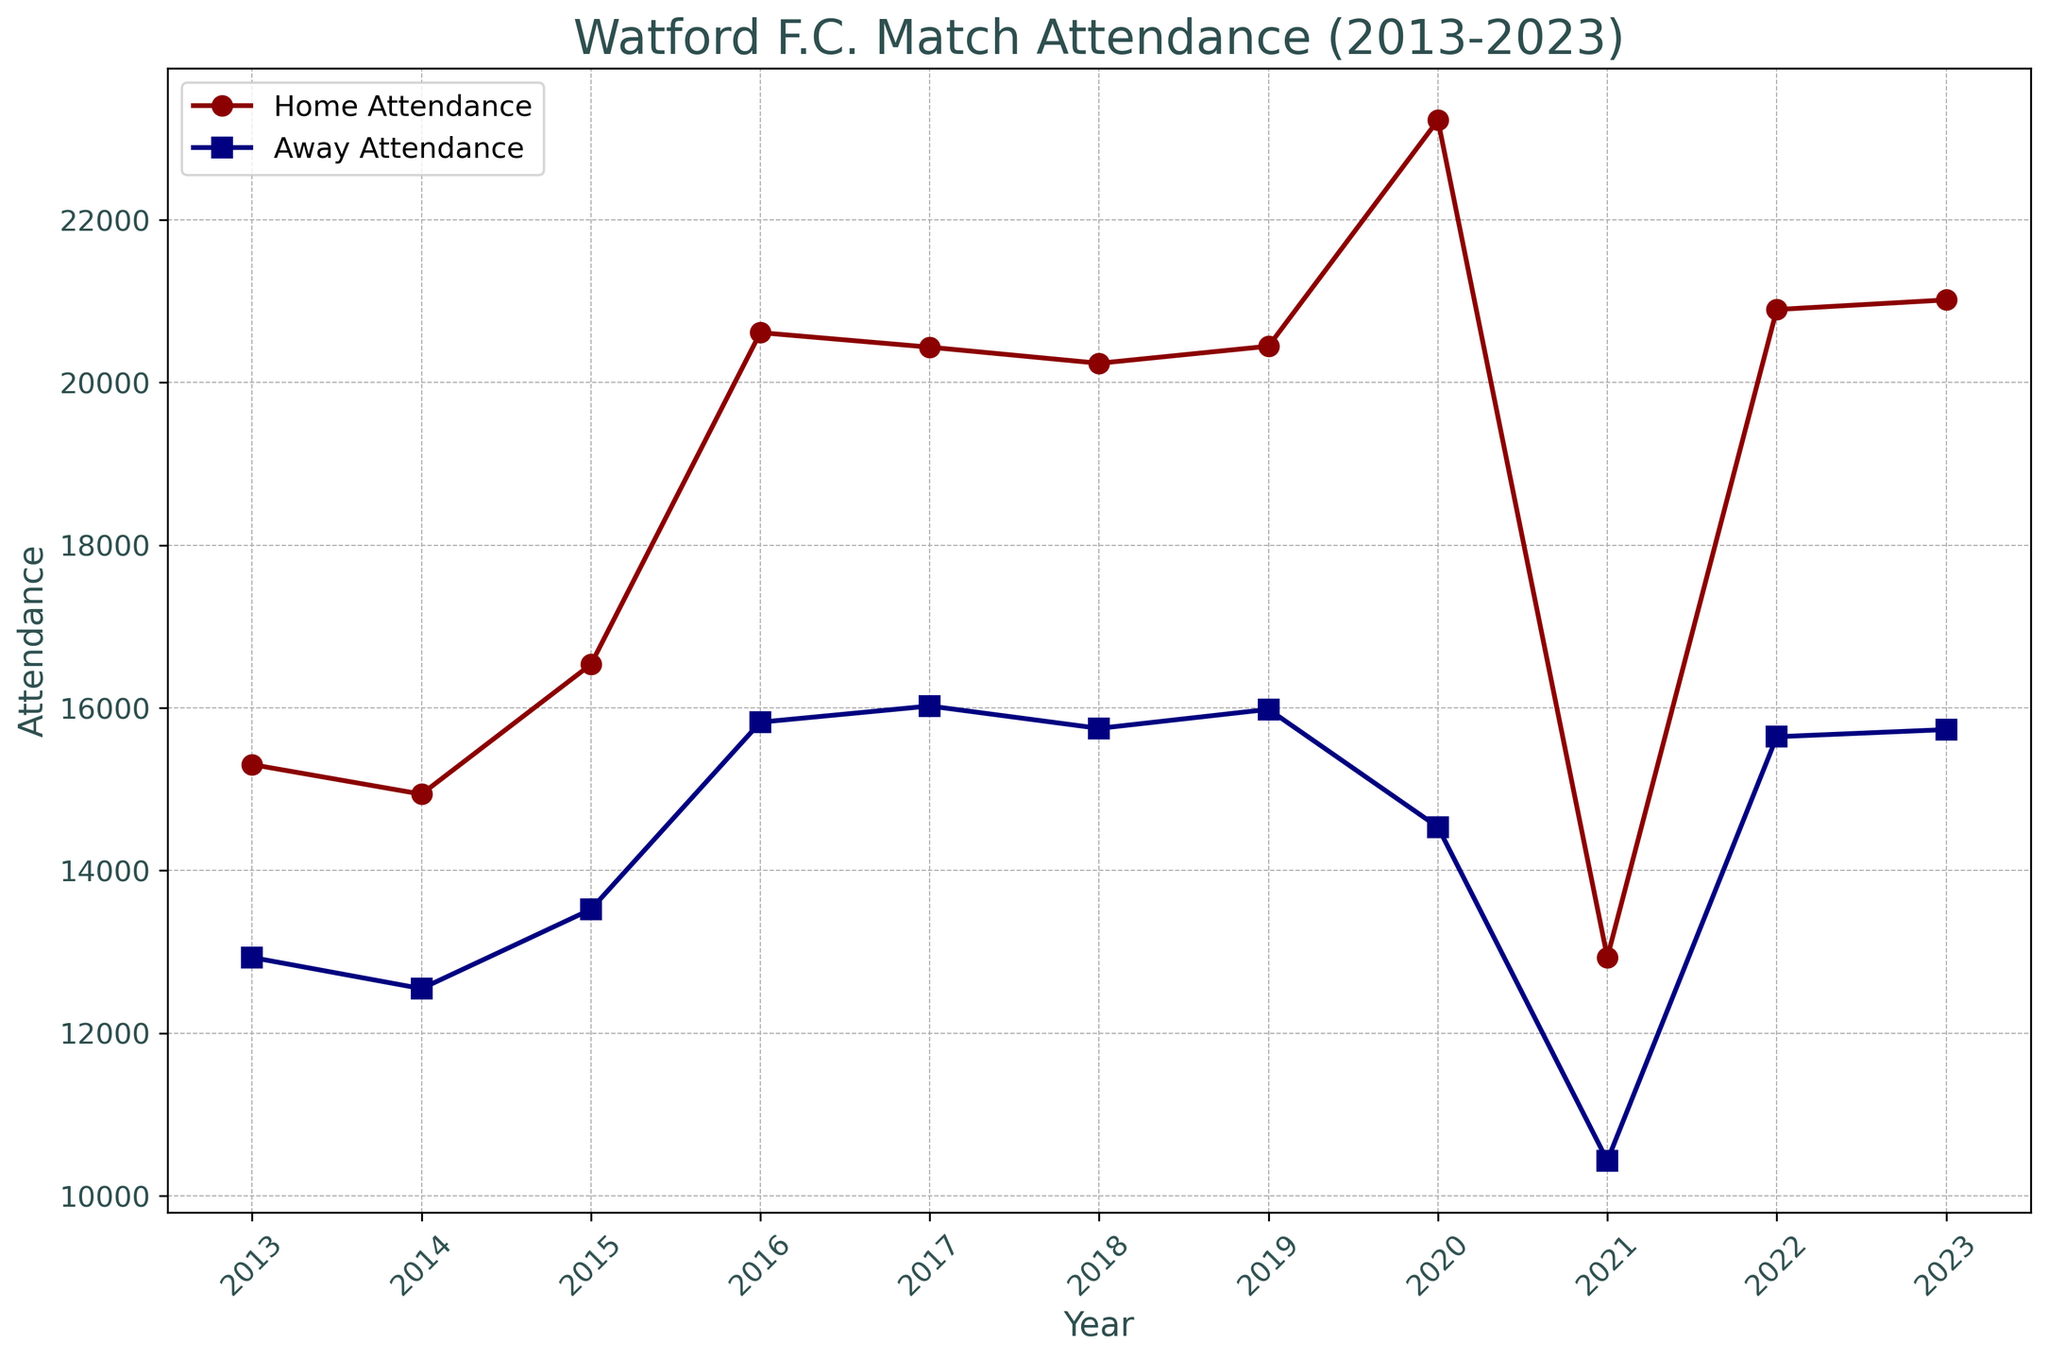Which year had the highest home attendance? According to the graph, the year with the highest home attendance is indicated as the peak value on the home attendance line. This peak occurs in the year 2020, showing an attendance of 23,225.
Answer: 2020 Which year had a larger difference between home and away attendance? To find this, look at each year and subtract the away attendance from the home attendance. The largest difference is in the year with the highest value for this subtraction. The year 2020 shows the largest difference where home attendance is 23,225 and away attendance is 14,534, making the difference 8,691.
Answer: 2020 In which years did the home attendance surpass 20,000? By examining the line for home attendance, the years where the value crosses 20,000 are 2016, 2017, 2018, 2019, 2020, 2022, and 2023.
Answer: 2016, 2017, 2018, 2019, 2020, 2022, 2023 How did the home and away attendances change between 2019 and 2020? From 2019 to 2020, the home attendance increased from 20,446 to 23,225, and the away attendance decreased from 15,981 to 14,534.
Answer: Home attendance increased and away attendance decreased What was the average home attendance between 2013 and 2015? Sum the home attendance values for 2013, 2014, and 2015 (15,302 + 14,938 + 16,533 = 46,773) and divide by 3 to get the average, which is 15,924.
Answer: 15,924 Which year saw the smallest home attendance, and what was the attendance value? The smallest value on the home attendance line occurs in 2021, where the attendance is given as 12,932.
Answer: 2021, 12,932 How did the attendance trends differ between home and away games over the decade? Overall, home attendance shows a more substantial increase over the years, peaking in 2020, while away attendance remains relatively stable with slight changes, except for a notable dip in 2020 and 2021.
Answer: Home attendance increased more significantly; away attendance remained more stable Which year had nearly equal home and away attendances? Examine the years where the home and away attendance lines are close to each other. In 2018, home attendance was 20,236 and away attendance was 15,747 showing one of the smallest differences between the two values.
Answer: 2018 What was the range of away attendance across the given years? To find the range, subtract the smallest away attendance value (2021: 10,432) from the largest away attendance value (2017: 16,022). The calculation is 16,022 - 10,432 = 5,590.
Answer: 5,590 